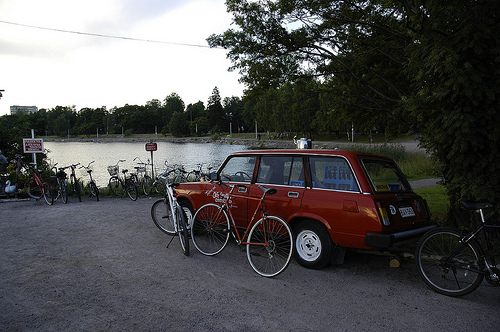<image>
Is there a water on the car? No. The water is not positioned on the car. They may be near each other, but the water is not supported by or resting on top of the car. 